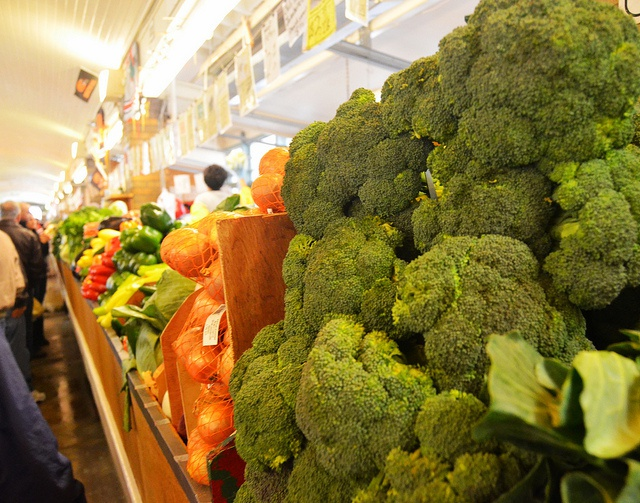Describe the objects in this image and their specific colors. I can see broccoli in khaki, olive, and black tones, people in khaki, black, gray, and maroon tones, orange in khaki, orange, red, and gold tones, people in khaki, black, tan, and maroon tones, and people in khaki, black, maroon, and gray tones in this image. 